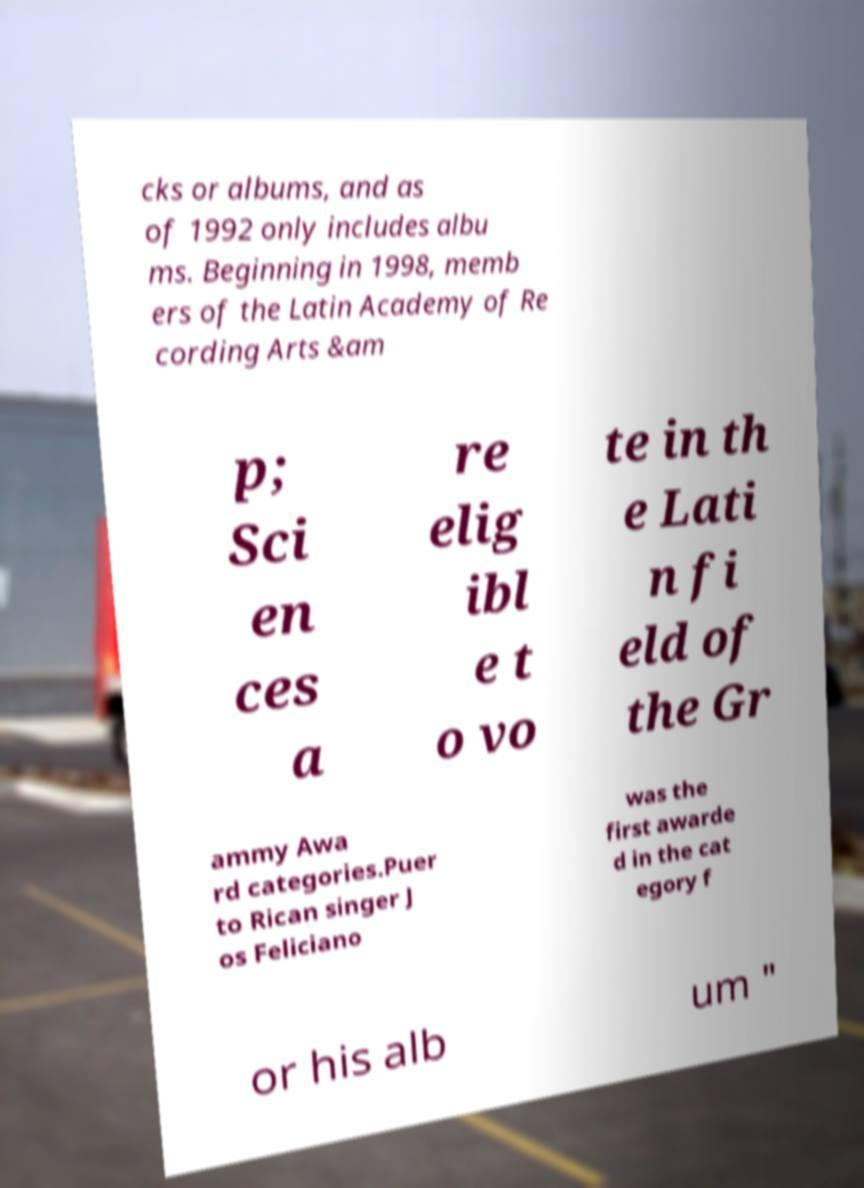Can you read and provide the text displayed in the image?This photo seems to have some interesting text. Can you extract and type it out for me? cks or albums, and as of 1992 only includes albu ms. Beginning in 1998, memb ers of the Latin Academy of Re cording Arts &am p; Sci en ces a re elig ibl e t o vo te in th e Lati n fi eld of the Gr ammy Awa rd categories.Puer to Rican singer J os Feliciano was the first awarde d in the cat egory f or his alb um " 